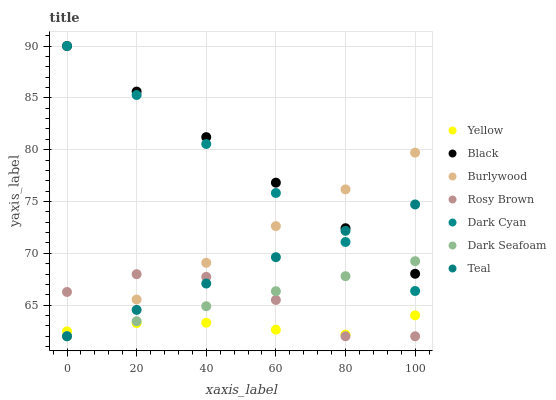Does Yellow have the minimum area under the curve?
Answer yes or no. Yes. Does Black have the maximum area under the curve?
Answer yes or no. Yes. Does Rosy Brown have the minimum area under the curve?
Answer yes or no. No. Does Rosy Brown have the maximum area under the curve?
Answer yes or no. No. Is Dark Cyan the smoothest?
Answer yes or no. Yes. Is Rosy Brown the roughest?
Answer yes or no. Yes. Is Yellow the smoothest?
Answer yes or no. No. Is Yellow the roughest?
Answer yes or no. No. Does Burlywood have the lowest value?
Answer yes or no. Yes. Does Yellow have the lowest value?
Answer yes or no. No. Does Dark Cyan have the highest value?
Answer yes or no. Yes. Does Rosy Brown have the highest value?
Answer yes or no. No. Is Rosy Brown less than Dark Cyan?
Answer yes or no. Yes. Is Dark Cyan greater than Yellow?
Answer yes or no. Yes. Does Dark Seafoam intersect Yellow?
Answer yes or no. Yes. Is Dark Seafoam less than Yellow?
Answer yes or no. No. Is Dark Seafoam greater than Yellow?
Answer yes or no. No. Does Rosy Brown intersect Dark Cyan?
Answer yes or no. No. 